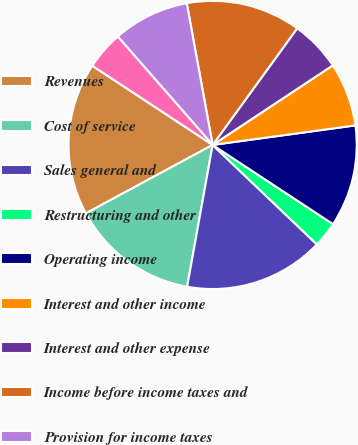Convert chart to OTSL. <chart><loc_0><loc_0><loc_500><loc_500><pie_chart><fcel>Revenues<fcel>Cost of service<fcel>Sales general and<fcel>Restructuring and other<fcel>Operating income<fcel>Interest and other income<fcel>Interest and other expense<fcel>Income before income taxes and<fcel>Provision for income taxes<fcel>Minority interest net of tax<nl><fcel>17.14%<fcel>14.29%<fcel>15.71%<fcel>2.86%<fcel>11.43%<fcel>7.14%<fcel>5.71%<fcel>12.86%<fcel>8.57%<fcel>4.29%<nl></chart> 